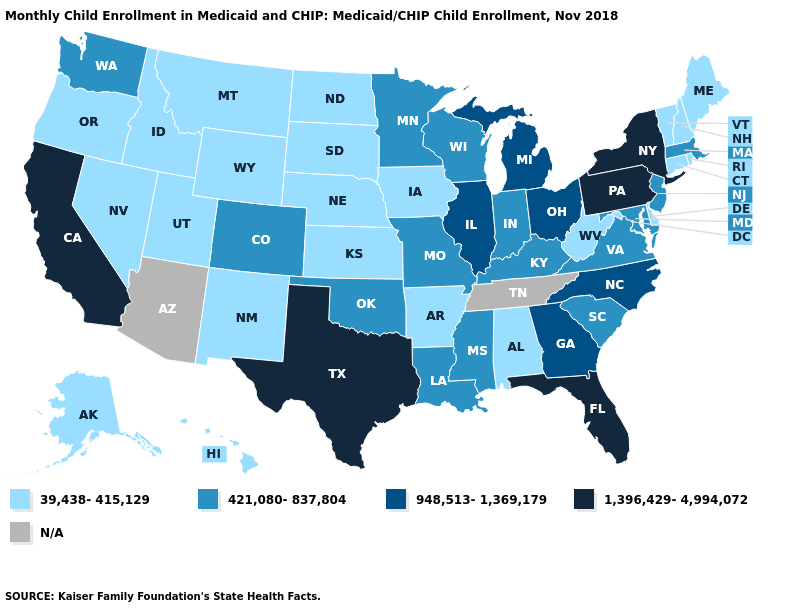Does California have the highest value in the West?
Be succinct. Yes. Does Ohio have the lowest value in the USA?
Keep it brief. No. Among the states that border Massachusetts , which have the highest value?
Quick response, please. New York. Name the states that have a value in the range 948,513-1,369,179?
Quick response, please. Georgia, Illinois, Michigan, North Carolina, Ohio. Name the states that have a value in the range 1,396,429-4,994,072?
Answer briefly. California, Florida, New York, Pennsylvania, Texas. Name the states that have a value in the range N/A?
Give a very brief answer. Arizona, Tennessee. Name the states that have a value in the range 421,080-837,804?
Quick response, please. Colorado, Indiana, Kentucky, Louisiana, Maryland, Massachusetts, Minnesota, Mississippi, Missouri, New Jersey, Oklahoma, South Carolina, Virginia, Washington, Wisconsin. What is the value of Virginia?
Concise answer only. 421,080-837,804. Name the states that have a value in the range 39,438-415,129?
Give a very brief answer. Alabama, Alaska, Arkansas, Connecticut, Delaware, Hawaii, Idaho, Iowa, Kansas, Maine, Montana, Nebraska, Nevada, New Hampshire, New Mexico, North Dakota, Oregon, Rhode Island, South Dakota, Utah, Vermont, West Virginia, Wyoming. What is the highest value in the South ?
Short answer required. 1,396,429-4,994,072. What is the value of Texas?
Keep it brief. 1,396,429-4,994,072. Is the legend a continuous bar?
Give a very brief answer. No. Name the states that have a value in the range 948,513-1,369,179?
Give a very brief answer. Georgia, Illinois, Michigan, North Carolina, Ohio. Does the map have missing data?
Be succinct. Yes. 